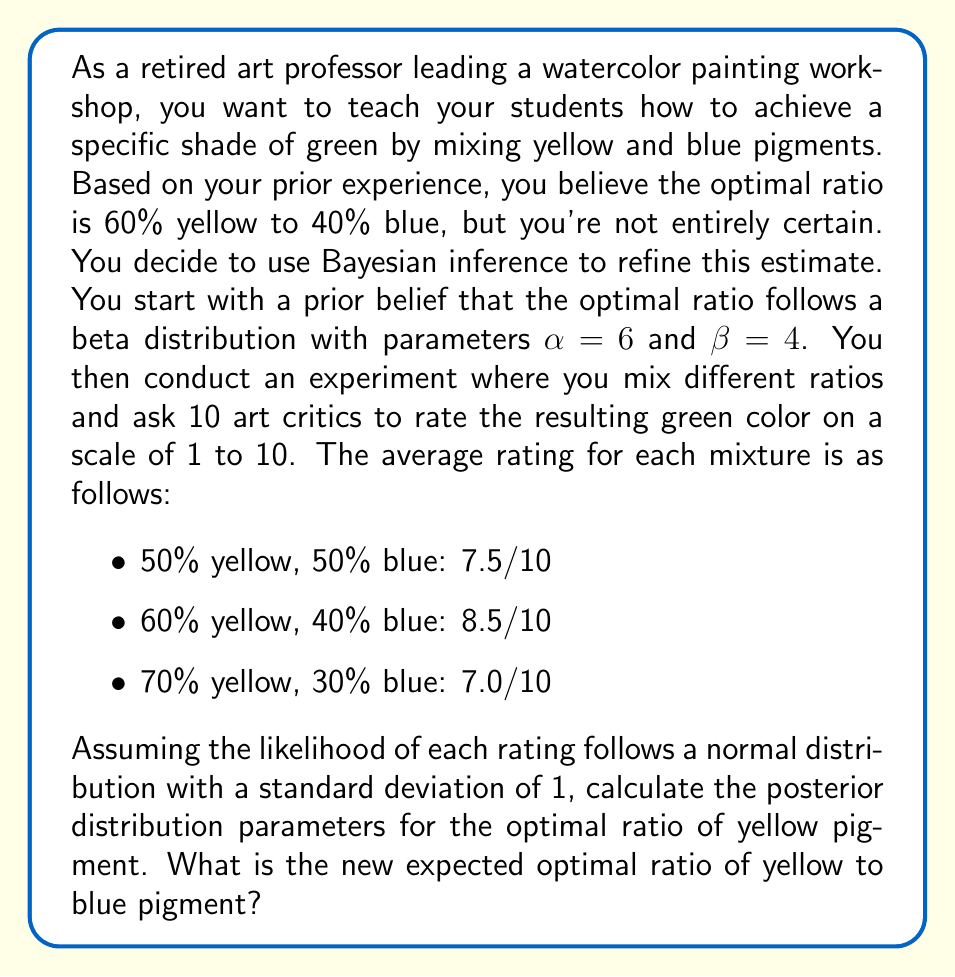What is the answer to this math problem? To solve this problem using Bayesian inference, we'll follow these steps:

1) Define the prior distribution:
   Our prior belief follows a Beta($\alpha, \beta$) distribution with $\alpha = 6$ and $\beta = 4$.

2) Define the likelihood function:
   We assume the ratings follow a normal distribution with mean $\mu$ (the true optimal ratio) and standard deviation $\sigma = 1$.

3) Calculate the likelihood for each observation:
   The likelihood is proportional to $\exp(-\frac{1}{2}(\frac{x - \mu}{\sigma})^2)$, where $x$ is the observed rating and $\mu$ is the proportion of yellow pigment.

4) Update the prior with each observation:
   For a Beta prior and normal likelihood, the posterior is approximately Beta distributed with updated parameters:

   $$\alpha_{new} = \alpha + \frac{\sum_{i=1}^n x_i}{\sigma^2}$$
   $$\beta_{new} = \beta + \frac{n}{\sigma^2} - \frac{\sum_{i=1}^n x_i}{\sigma^2}$$

   Where $n$ is the number of observations, $x_i$ are the observed ratios weighted by their ratings.

5) Calculate the weighted sum of observations:
   $(0.5 * 7.5 + 0.6 * 8.5 + 0.7 * 7.0) = 3.75 + 5.1 + 4.9 = 13.75$

6) Update the parameters:
   $$\alpha_{new} = 6 + \frac{13.75}{1^2} = 19.75$$
   $$\beta_{new} = 4 + \frac{3}{1^2} - \frac{13.75}{1^2} = 13.25$$

7) Calculate the expected value of the posterior Beta distribution:
   $$E[X] = \frac{\alpha_{new}}{\alpha_{new} + \beta_{new}} = \frac{19.75}{19.75 + 13.25} \approx 0.5985$$

This gives us the new expected optimal ratio of yellow pigment.
Answer: The posterior distribution for the optimal ratio of yellow pigment is approximately Beta(19.75, 13.25). The new expected optimal ratio is approximately 59.85% yellow to 40.15% blue. 